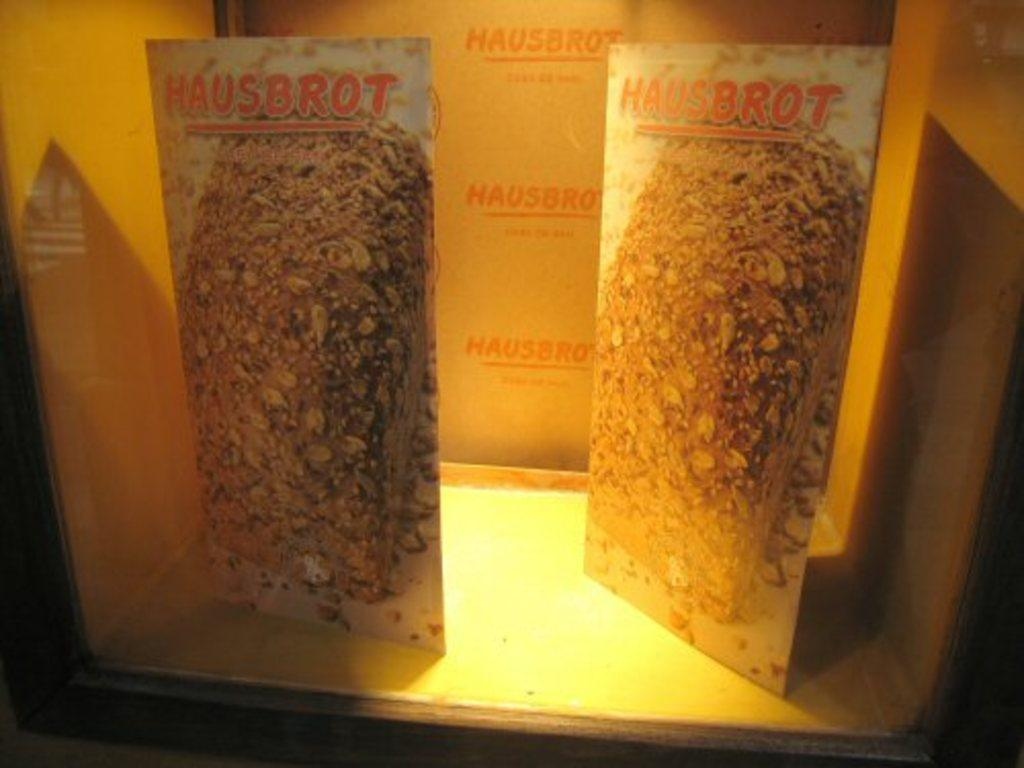What objects are present in the image? There are boards and a cardboard box in the image. How are the boards arranged in the image? The boards are placed in a cardboard box. Is there any text visible in the image? Yes, there is text in the image. What type of apparel is being worn by the dinosaurs in the image? There are no dinosaurs or apparel present in the image. Can you describe the tub that the boards are sitting in within the image? There is no tub present in the image; the boards are placed in a cardboard box. 